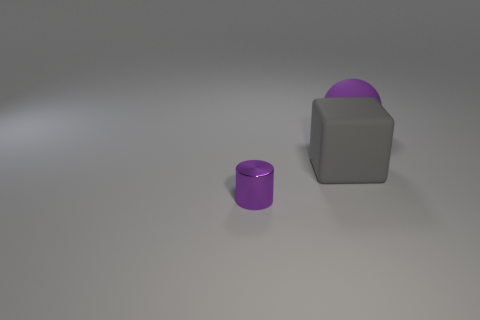Add 2 small metal objects. How many objects exist? 5 Subtract all spheres. How many objects are left? 2 Add 2 tiny red cubes. How many tiny red cubes exist? 2 Subtract 0 blue cylinders. How many objects are left? 3 Subtract all large purple metal things. Subtract all shiny things. How many objects are left? 2 Add 1 purple spheres. How many purple spheres are left? 2 